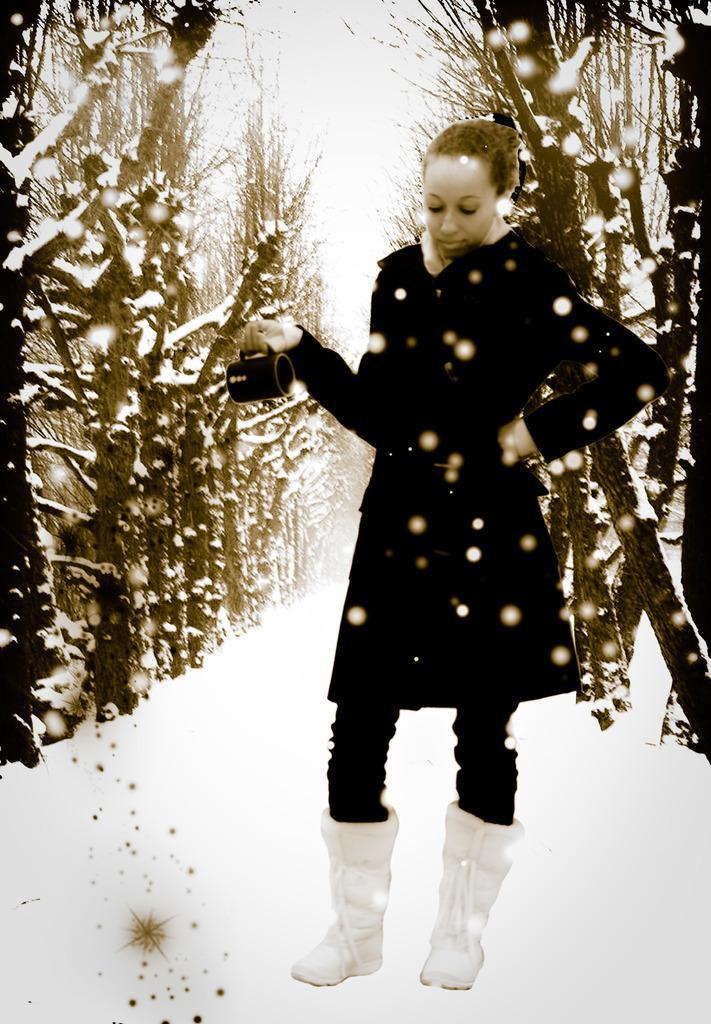Please provide a concise description of this image. In this image in front there is a person holding the mug. Behind her there are trees. In the background of the image there is sky. At the bottom of the image there is snow on the surface. 